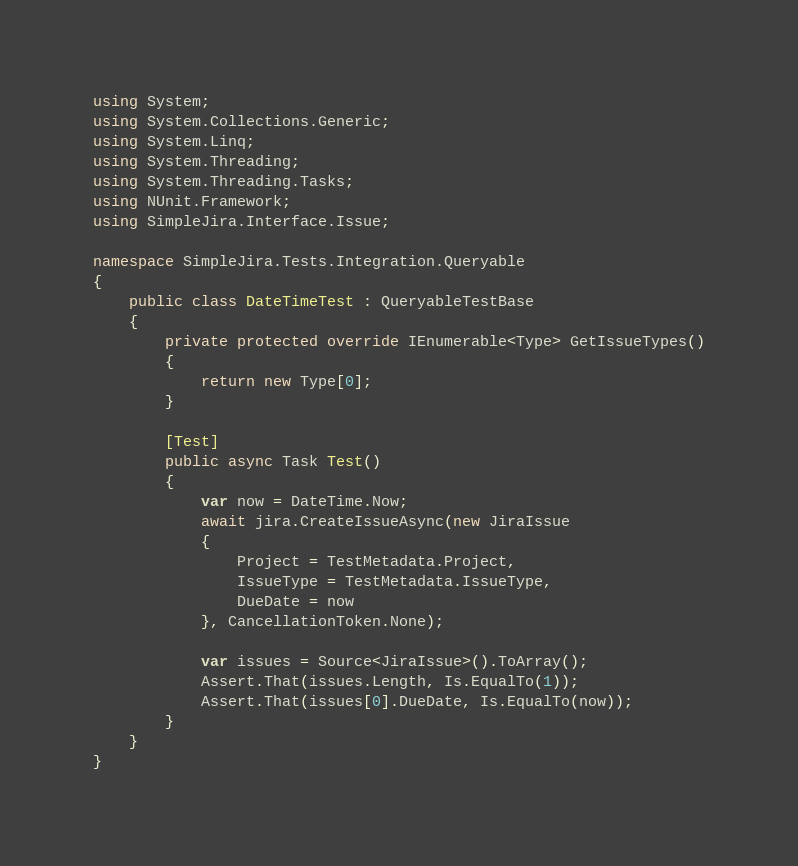Convert code to text. <code><loc_0><loc_0><loc_500><loc_500><_C#_>using System;
using System.Collections.Generic;
using System.Linq;
using System.Threading;
using System.Threading.Tasks;
using NUnit.Framework;
using SimpleJira.Interface.Issue;

namespace SimpleJira.Tests.Integration.Queryable
{
    public class DateTimeTest : QueryableTestBase
    {
        private protected override IEnumerable<Type> GetIssueTypes()
        {
            return new Type[0];
        }

        [Test]
        public async Task Test()
        {
            var now = DateTime.Now;
            await jira.CreateIssueAsync(new JiraIssue
            {
                Project = TestMetadata.Project,
                IssueType = TestMetadata.IssueType,
                DueDate = now
            }, CancellationToken.None);

            var issues = Source<JiraIssue>().ToArray();
            Assert.That(issues.Length, Is.EqualTo(1));
            Assert.That(issues[0].DueDate, Is.EqualTo(now));
        }
    }
}</code> 